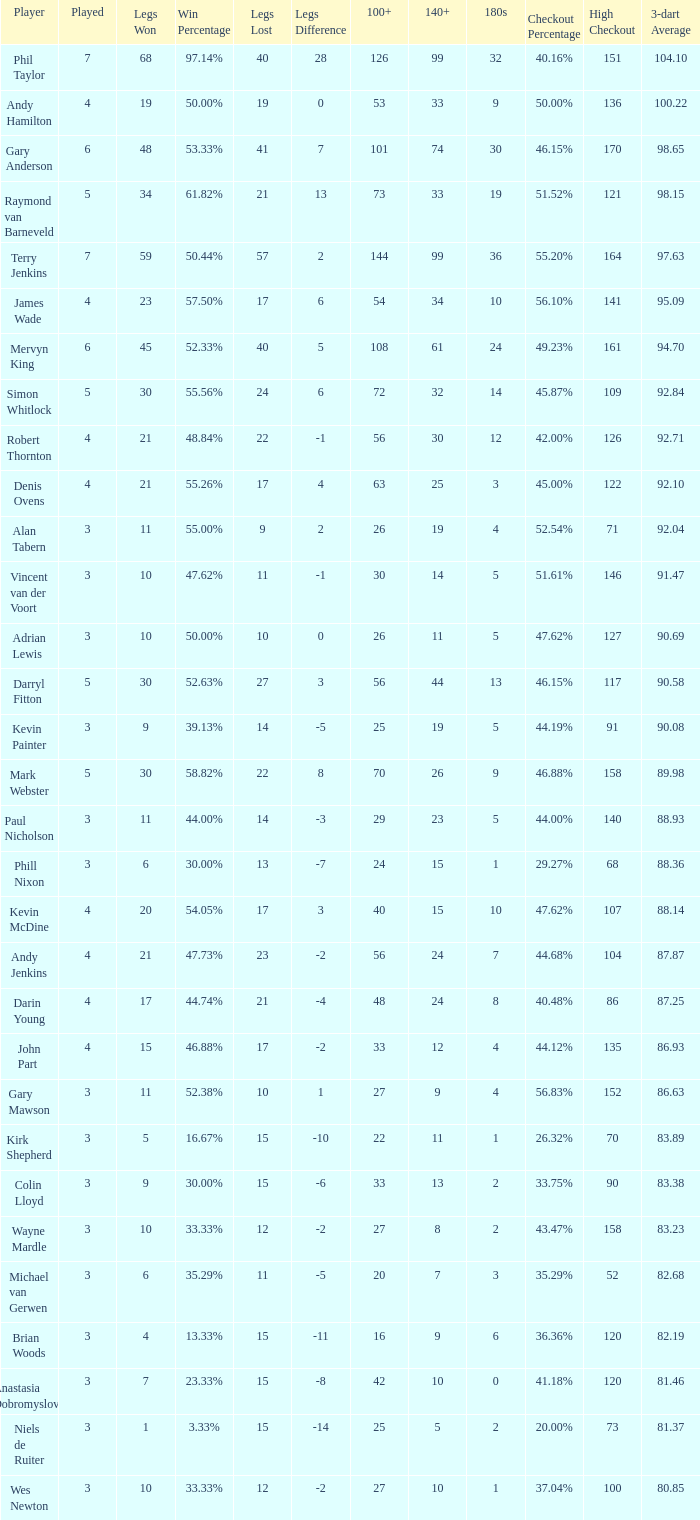Who is the player with 41 legs lost? Gary Anderson. Could you parse the entire table? {'header': ['Player', 'Played', 'Legs Won', 'Win Percentage', 'Legs Lost', 'Legs Difference', '100+', '140+', '180s', 'Checkout Percentage', 'High Checkout', '3-dart Average'], 'rows': [['Phil Taylor', '7', '68', '97.14%', '40', '28', '126', '99', '32', '40.16%', '151', '104.10'], ['Andy Hamilton', '4', '19', '50.00%', '19', '0', '53', '33', '9', '50.00%', '136', '100.22'], ['Gary Anderson', '6', '48', '53.33%', '41', '7', '101', '74', '30', '46.15%', '170', '98.65'], ['Raymond van Barneveld', '5', '34', '61.82%', '21', '13', '73', '33', '19', '51.52%', '121', '98.15'], ['Terry Jenkins', '7', '59', '50.44%', '57', '2', '144', '99', '36', '55.20%', '164', '97.63'], ['James Wade', '4', '23', '57.50%', '17', '6', '54', '34', '10', '56.10%', '141', '95.09'], ['Mervyn King', '6', '45', '52.33%', '40', '5', '108', '61', '24', '49.23%', '161', '94.70'], ['Simon Whitlock', '5', '30', '55.56%', '24', '6', '72', '32', '14', '45.87%', '109', '92.84'], ['Robert Thornton', '4', '21', '48.84%', '22', '-1', '56', '30', '12', '42.00%', '126', '92.71'], ['Denis Ovens', '4', '21', '55.26%', '17', '4', '63', '25', '3', '45.00%', '122', '92.10'], ['Alan Tabern', '3', '11', '55.00%', '9', '2', '26', '19', '4', '52.54%', '71', '92.04'], ['Vincent van der Voort', '3', '10', '47.62%', '11', '-1', '30', '14', '5', '51.61%', '146', '91.47'], ['Adrian Lewis', '3', '10', '50.00%', '10', '0', '26', '11', '5', '47.62%', '127', '90.69'], ['Darryl Fitton', '5', '30', '52.63%', '27', '3', '56', '44', '13', '46.15%', '117', '90.58'], ['Kevin Painter', '3', '9', '39.13%', '14', '-5', '25', '19', '5', '44.19%', '91', '90.08'], ['Mark Webster', '5', '30', '58.82%', '22', '8', '70', '26', '9', '46.88%', '158', '89.98'], ['Paul Nicholson', '3', '11', '44.00%', '14', '-3', '29', '23', '5', '44.00%', '140', '88.93'], ['Phill Nixon', '3', '6', '30.00%', '13', '-7', '24', '15', '1', '29.27%', '68', '88.36'], ['Kevin McDine', '4', '20', '54.05%', '17', '3', '40', '15', '10', '47.62%', '107', '88.14'], ['Andy Jenkins', '4', '21', '47.73%', '23', '-2', '56', '24', '7', '44.68%', '104', '87.87'], ['Darin Young', '4', '17', '44.74%', '21', '-4', '48', '24', '8', '40.48%', '86', '87.25'], ['John Part', '4', '15', '46.88%', '17', '-2', '33', '12', '4', '44.12%', '135', '86.93'], ['Gary Mawson', '3', '11', '52.38%', '10', '1', '27', '9', '4', '56.83%', '152', '86.63'], ['Kirk Shepherd', '3', '5', '16.67%', '15', '-10', '22', '11', '1', '26.32%', '70', '83.89'], ['Colin Lloyd', '3', '9', '30.00%', '15', '-6', '33', '13', '2', '33.75%', '90', '83.38'], ['Wayne Mardle', '3', '10', '33.33%', '12', '-2', '27', '8', '2', '43.47%', '158', '83.23'], ['Michael van Gerwen', '3', '6', '35.29%', '11', '-5', '20', '7', '3', '35.29%', '52', '82.68'], ['Brian Woods', '3', '4', '13.33%', '15', '-11', '16', '9', '6', '36.36%', '120', '82.19'], ['Anastasia Dobromyslova', '3', '7', '23.33%', '15', '-8', '42', '10', '0', '41.18%', '120', '81.46'], ['Niels de Ruiter', '3', '1', '3.33%', '15', '-14', '25', '5', '2', '20.00%', '73', '81.37'], ['Wes Newton', '3', '10', '33.33%', '12', '-2', '27', '10', '1', '37.04%', '100', '80.85']]} 